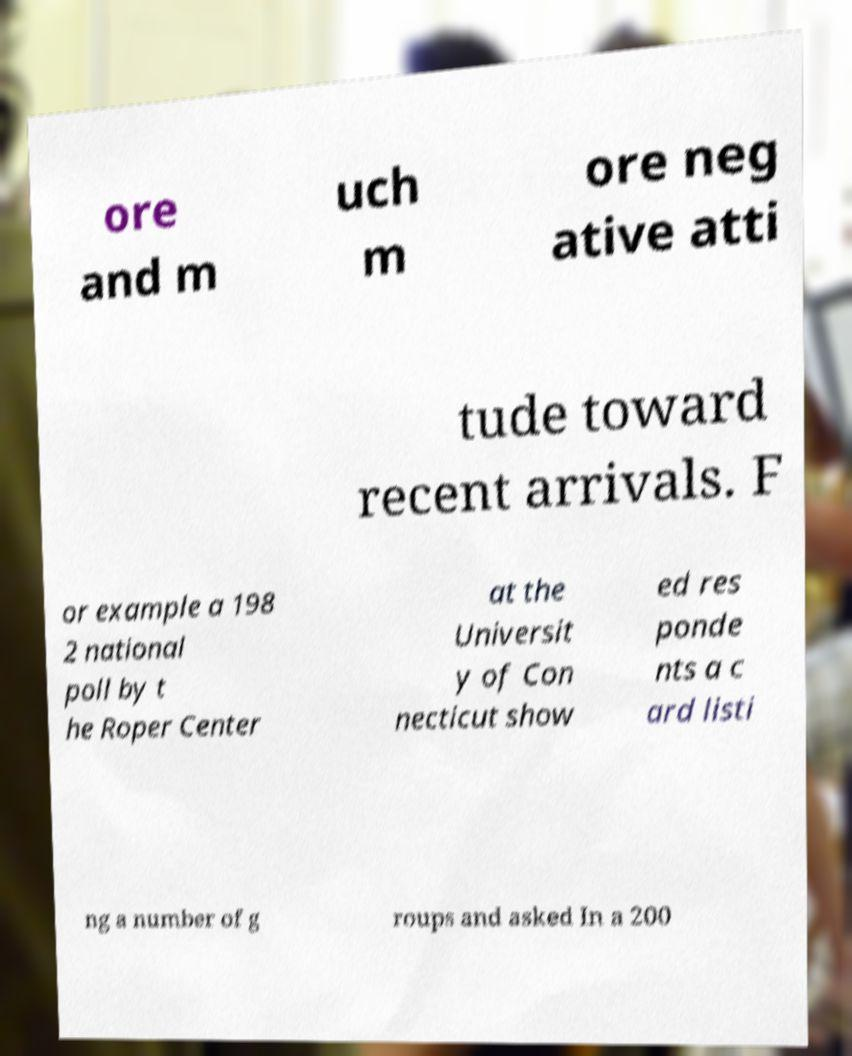There's text embedded in this image that I need extracted. Can you transcribe it verbatim? ore and m uch m ore neg ative atti tude toward recent arrivals. F or example a 198 2 national poll by t he Roper Center at the Universit y of Con necticut show ed res ponde nts a c ard listi ng a number of g roups and asked In a 200 